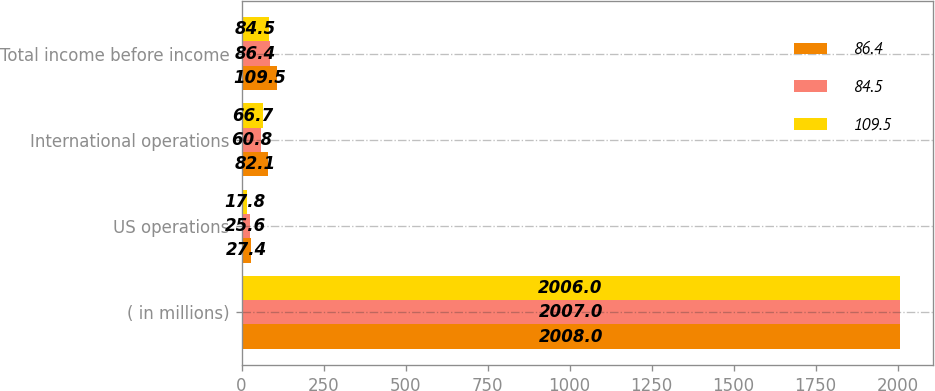Convert chart. <chart><loc_0><loc_0><loc_500><loc_500><stacked_bar_chart><ecel><fcel>( in millions)<fcel>US operations<fcel>International operations<fcel>Total income before income<nl><fcel>86.4<fcel>2008<fcel>27.4<fcel>82.1<fcel>109.5<nl><fcel>84.5<fcel>2007<fcel>25.6<fcel>60.8<fcel>86.4<nl><fcel>109.5<fcel>2006<fcel>17.8<fcel>66.7<fcel>84.5<nl></chart> 